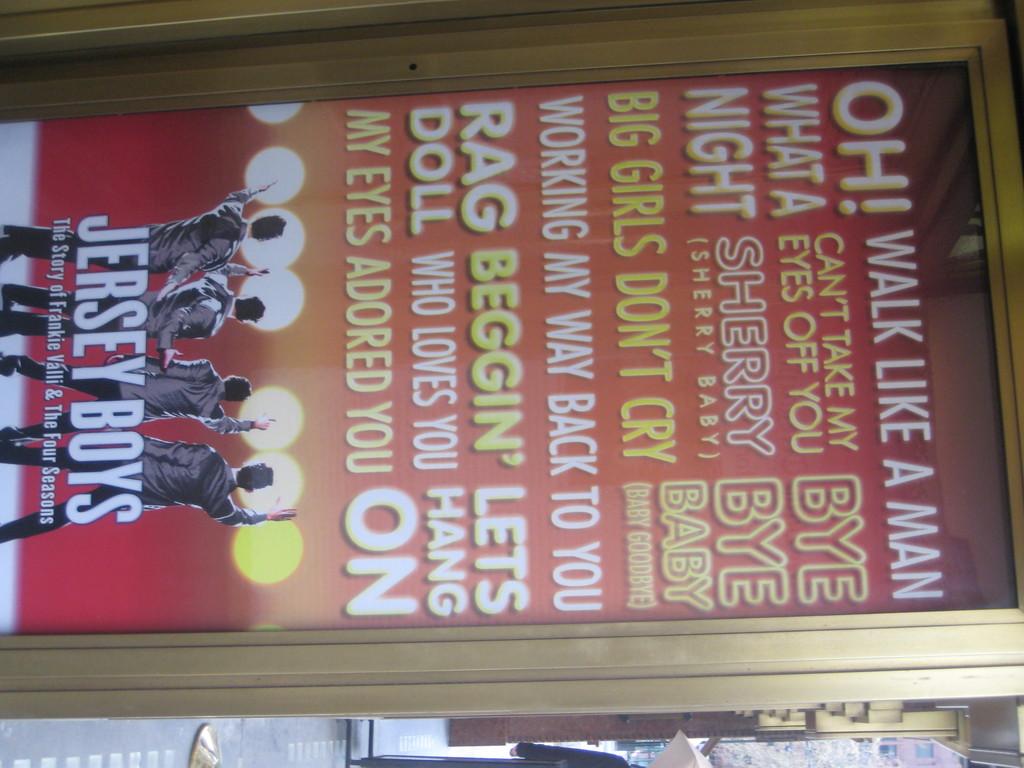What is being said on the plaque?
Provide a short and direct response. Walk like a man. Who is performing?
Make the answer very short. Jersey boys. 